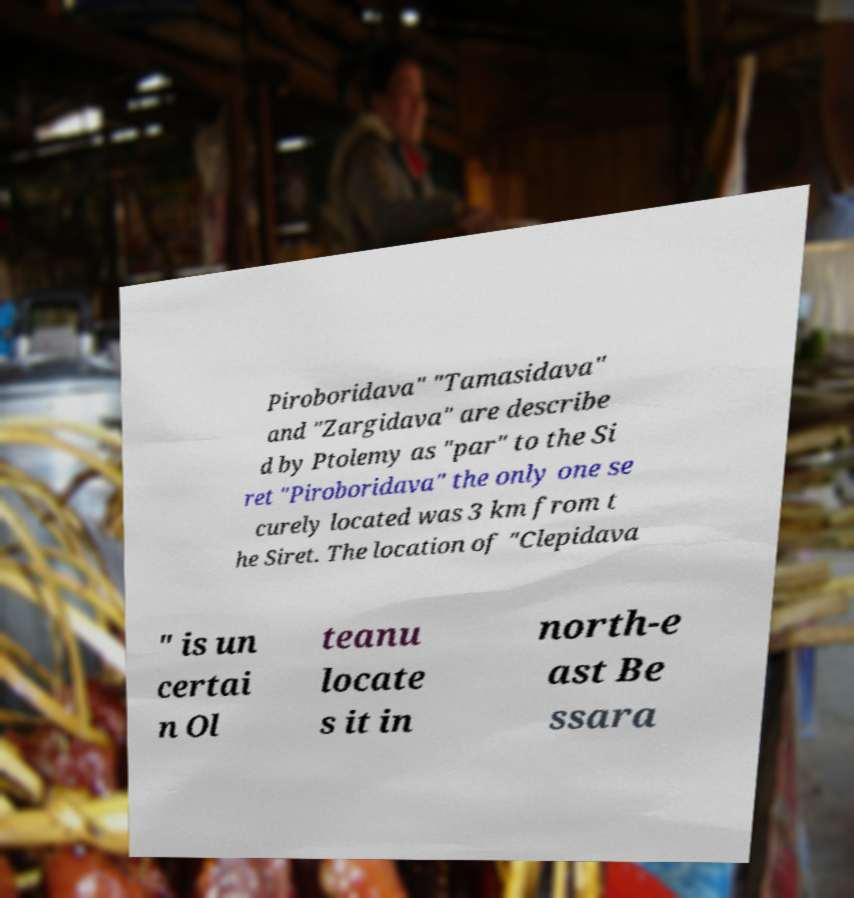Please identify and transcribe the text found in this image. Piroboridava" "Tamasidava" and "Zargidava" are describe d by Ptolemy as "par" to the Si ret "Piroboridava" the only one se curely located was 3 km from t he Siret. The location of "Clepidava " is un certai n Ol teanu locate s it in north-e ast Be ssara 